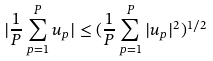<formula> <loc_0><loc_0><loc_500><loc_500>| \frac { 1 } { P } \sum _ { p = 1 } ^ { P } u _ { p } | \leq ( \frac { 1 } { P } \sum _ { p = 1 } ^ { P } | u _ { p } | ^ { 2 } ) ^ { 1 / 2 }</formula> 